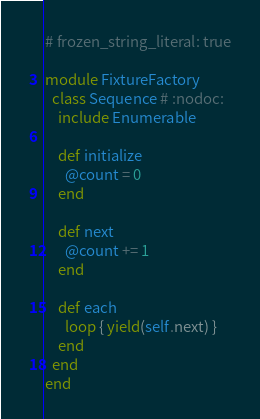<code> <loc_0><loc_0><loc_500><loc_500><_Ruby_># frozen_string_literal: true

module FixtureFactory
  class Sequence # :nodoc:
    include Enumerable

    def initialize
      @count = 0
    end

    def next
      @count += 1
    end

    def each
      loop { yield(self.next) }
    end
  end
end
</code> 